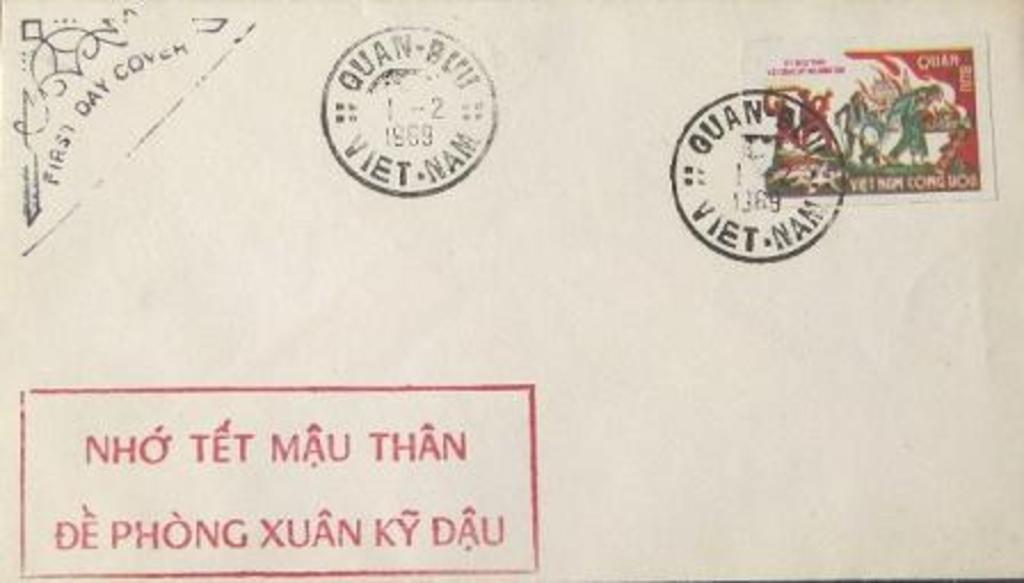<image>
Offer a succinct explanation of the picture presented. A Vietnamese envelop is covered with stamps and stickers. 